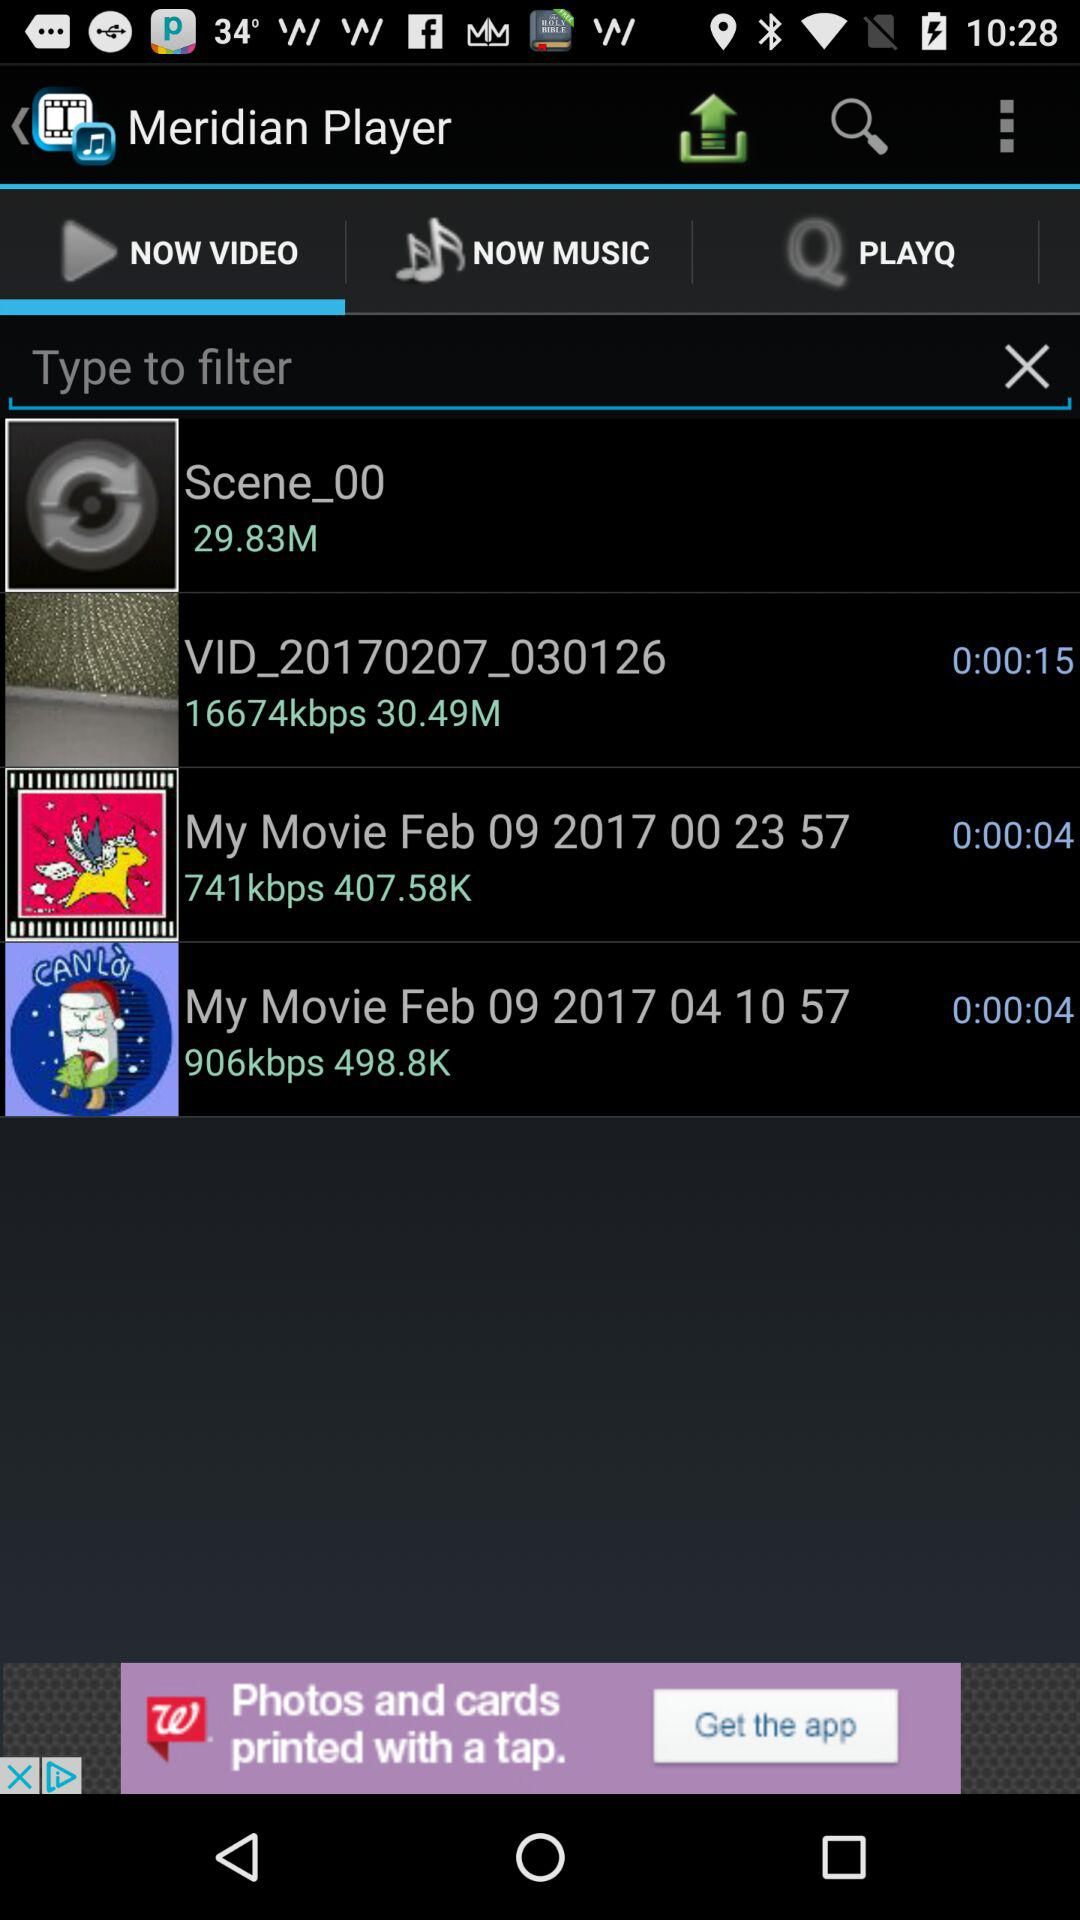What is the duration of the video "My Movie Feb 09 2017 04 10 57"? The duration of the video is 4 seconds. 